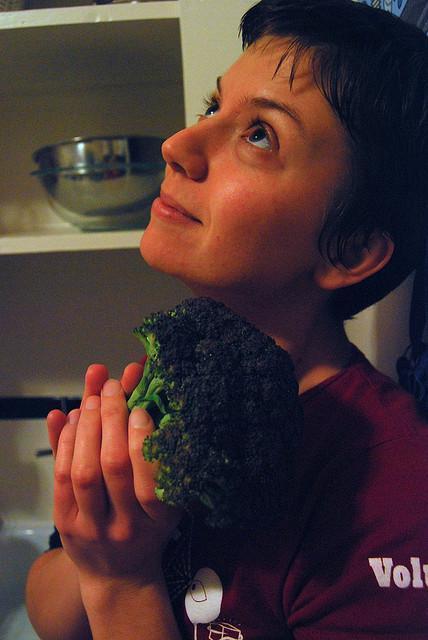How many horses are shown?
Give a very brief answer. 0. 